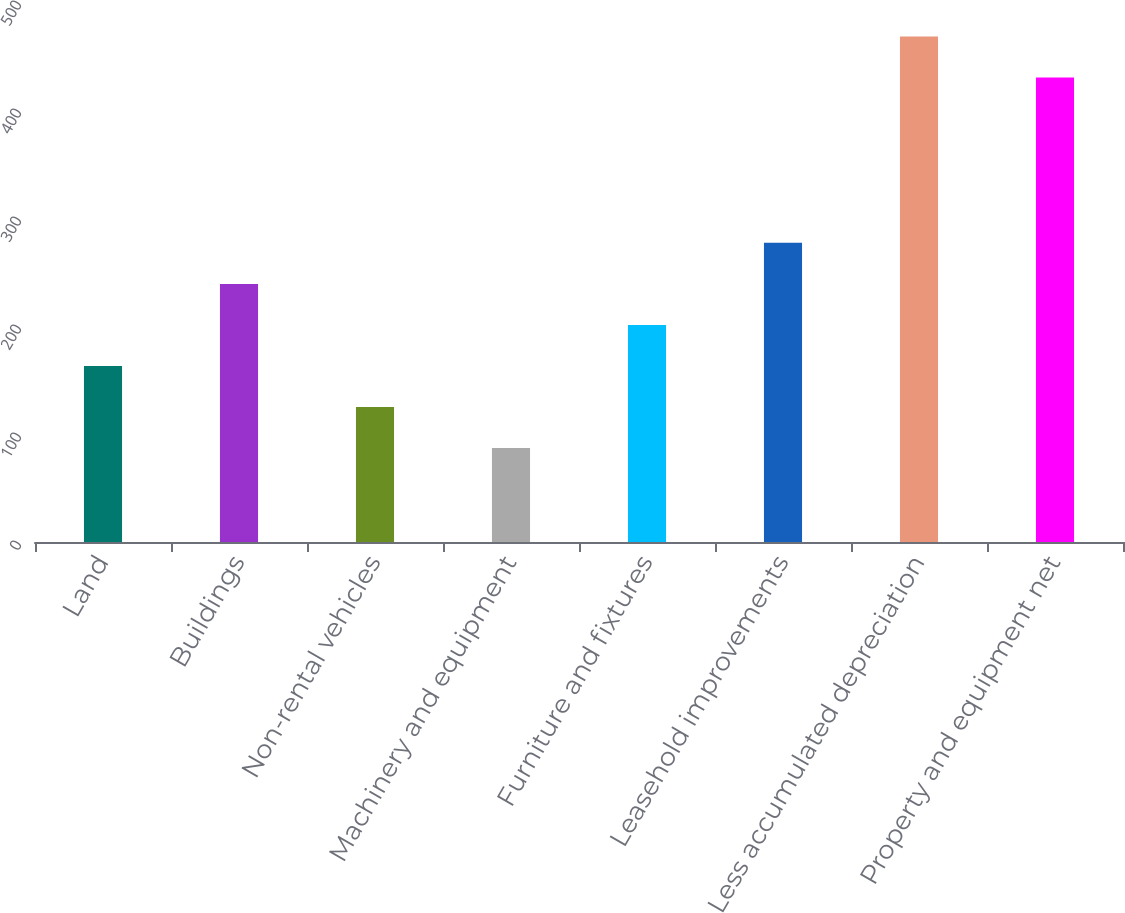<chart> <loc_0><loc_0><loc_500><loc_500><bar_chart><fcel>Land<fcel>Buildings<fcel>Non-rental vehicles<fcel>Machinery and equipment<fcel>Furniture and fixtures<fcel>Leasehold improvements<fcel>Less accumulated depreciation<fcel>Property and equipment net<nl><fcel>163<fcel>239<fcel>125<fcel>87<fcel>201<fcel>277<fcel>468<fcel>430<nl></chart> 